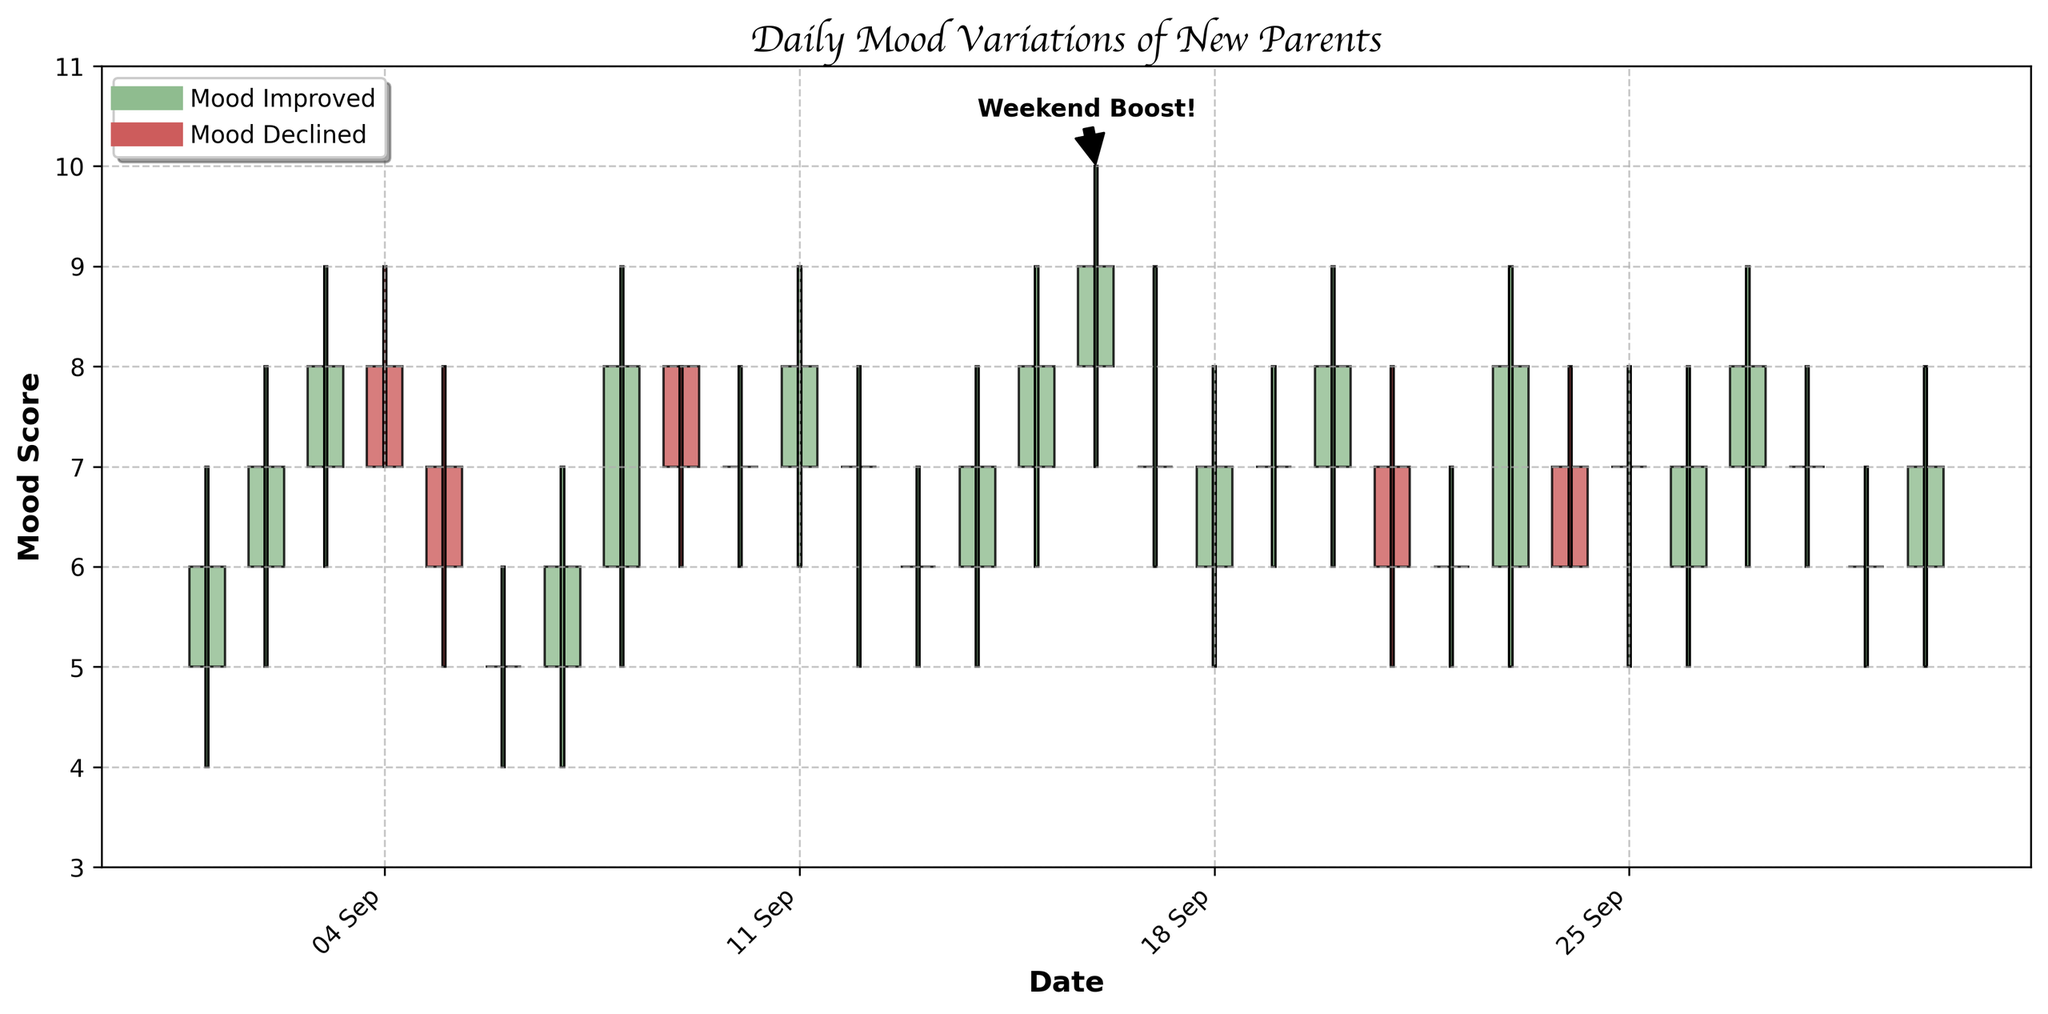What is the title of the candlestick plot? The title of the candlestick plot is usually shown at the top of the figure. In this case, the title is "Daily Mood Variations of New Parents".
Answer: Daily Mood Variations of New Parents How many days show an improvement in mood (green bars)? To find the number of days with mood improvement, count the green bars in the figure. Green bars indicate days where the Close Mood Score is greater than or equal to the Open Mood Score.
Answer: 19 days Which date has the highest mood variation and what is the range of mood scores on that date? To determine the date with the highest variation, find the date with the tallest candlestick (the longest high to low line). The tally reveals September 16th has the highest variation (High Mood Score of 10 and Low Mood Score of 7). The range is calculated as 10 - 7.
Answer: September 16th, 3 On which weekend did the mood annotations indicate a 'Weekend Boost!'? Look for the annotation label "Weekend Boost!" and identify the specific date it refers to. The annotation points to the weekend around the 15th.
Answer: September 16th What is the median Close Mood Score for the days where mood improved? To find the median, first list the Close Mood Scores for the days with improved mood (green bars). Then, sort these scores and find the middle value through a median calculation. Scores: 6, 7, 8, 7, 6, 5, 6, 8, 7, 7, 8, 7, 7, 8, 9, 7, 6, 8, 7. Sorted Scores: 5, 6, 6, 6, 7, 7, 7, 7, 7, 7, 7, 8, 8, 8, 8, 8, 9. Median is the 10th value.
Answer: 7 Which date shows the smallest increase in mood score from Open to Close among the days with mood improvement? Analyze the height of the green bodies in the figure where the Close Mood Score is just slightly higher than the Open Mood Score. The smallest increase appears on September 19 with the increase of 0 units (Open 7, Close 7).
Answer: September 19 How many days did the mood decline? Count the red bars in the figure. The red bars indicate a drop in mood from Open Mood Score to Close Mood Score.
Answer: 11 days What is the average High Mood Score for the entire month? Sum the High Mood Scores for each day and divide by the total number of days (30). Total Sum: 9+8+9+9+8+6+7+9+8+8+9+8+7+8+9+10+9+8+8+9+8+7+9+8+8+8+9+8+7+8 = 239. Average = 239/30.
Answer: 7.97 Compare the mood on consecutive weekends (dates: Sep 2-3 and Sep 9-10). Was there more significant improvement or decline on any particular weekend? For the weekends, calculate the average difference between Open Mood Score and Close Mood Score. For Sep 2-3, changes (1+1)/2 = 1. For Sep 9-10, changes (-1+1)/2 = 0.
Answer: Sep 2-3 had more significant improvement What was the maximum Close Mood Score recorded during the month? Look for the highest Close Mood Score in the figure. The data indicates that the maximum Close Mood Score recorded is 9 on multiple days.
Answer: 9 